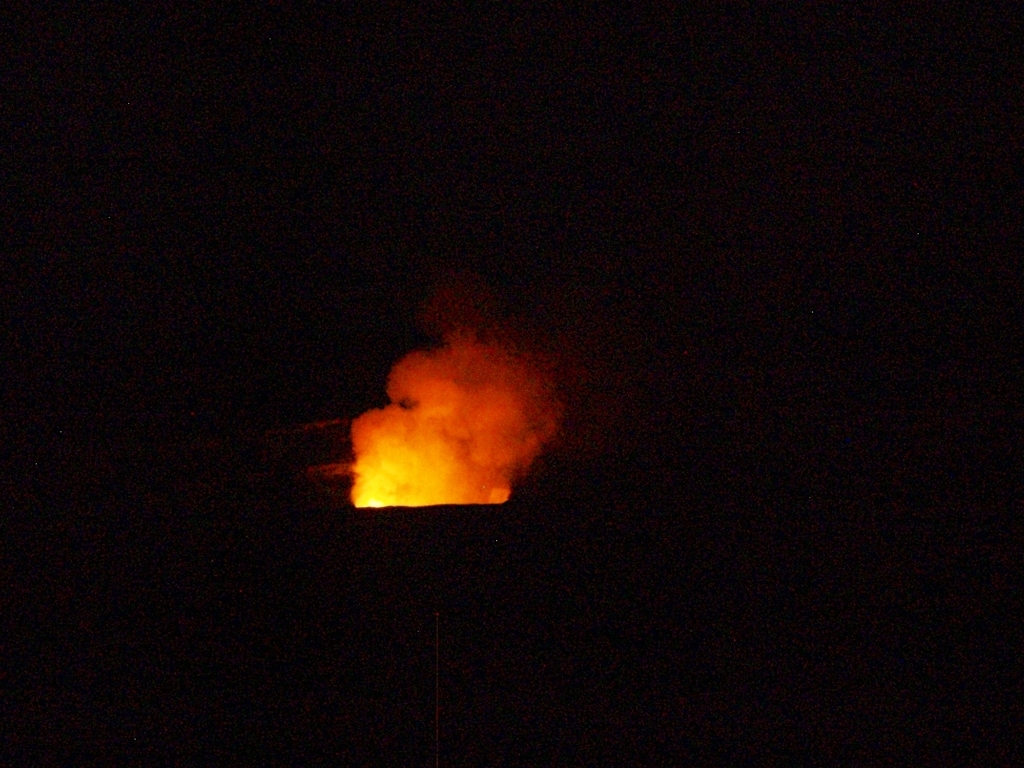What event is taking place in this image? The image appears to capture an active fire event, possibly a controlled burn or a natural wildfire, evidenced by the bright flames against the night sky. The exact context isn't clear without additional information, but the image evokes the dynamic and potentially destructive nature of fire. 